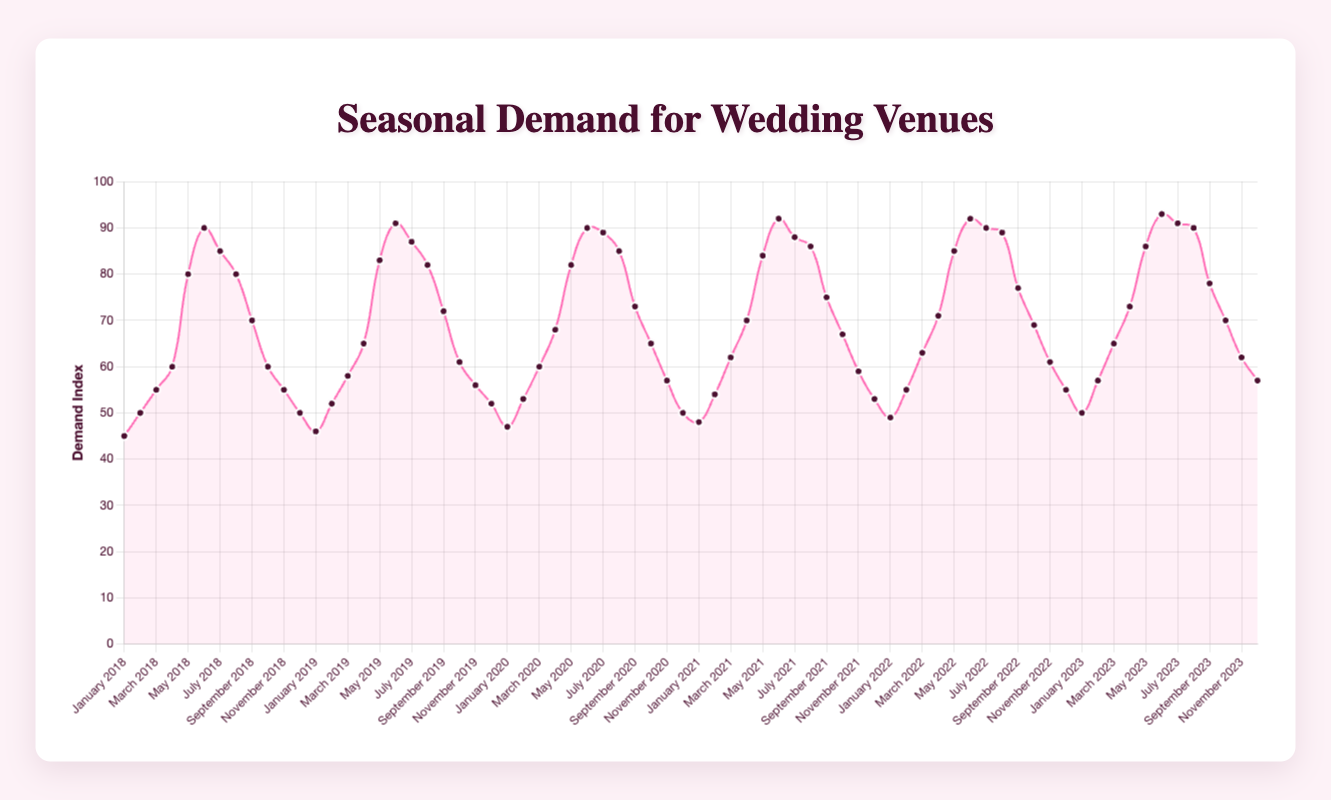Which month consistently has the highest wedding venue demand across all the years? By looking at the graph, the month with the highest Demand Index each year is June. The peak for each year appears around June.
Answer: June Which year saw the highest demand in April? Looking at the demand indices for April over the years, April 2023 had the highest demand with a Demand Index of 73.
Answer: 2023 How does the demand for wedding venues in December 2021 compare to December 2022? December 2021 has a Demand Index of 53, while December 2022 has a Demand Index of 55. 55 is greater than 53, so December 2022 had a higher demand.
Answer: December 2022 Calculate the average demand index for June over the past five years. The demand indices for June are 90 (2018), 91 (2019), 90 (2020), 92 (2021), and 92 (2022). Sum these values: 90 + 91 + 90 + 92 + 92 = 455. The average is 455 / 5 = 91.
Answer: 91 What is the difference in demand index between the highest and lowest months in 2023? The highest demand index in 2023 is 93 (June), and the lowest is 50 (January). The difference is 93 - 50 = 43.
Answer: 43 Is the demand for wedding venues higher in spring (March-May) or in autumn (September-November) in 2020? Summing the demand indices for spring: March (60) + April (68) + May (82) = 210. Summing the indices for autumn: September (73) + October (65) + November (57) = 195. 210 is greater than 195, so spring has higher demand.
Answer: Spring Which month shows the steepest increase in demand from 2018 to 2019? By examining the changes month to month: January (1), February (2), March (3), April (5), May (3), June (1), July (2), August (2), September (2), October (1), November (1), December (2). March shows the steepest increase, from 55 to 58.
Answer: March How many months in the 2023 data show a demand index above 80? Reviewing each month in 2023, the months with demand indices above 80 are May (86), June (93), July (91), August (90), September (78 doesn't count). There are 4 months.
Answer: 4 